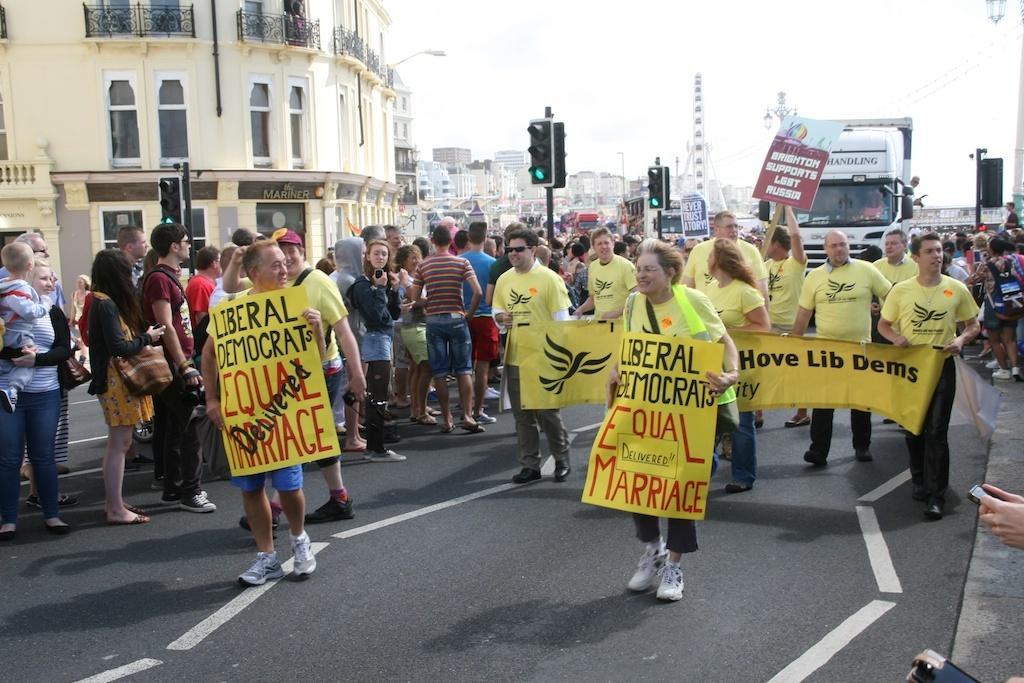Please provide a concise description of this image. In this picture we can observe some people walking on this road, holding yellow color poster in their hands. There were men and women in this picture. There were traffic signals to the poles. There is a white color vehicle moving on the road. In the left side there is a building. In the background we can observe a tower and a sky. 